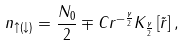<formula> <loc_0><loc_0><loc_500><loc_500>n _ { \uparrow ( \downarrow ) } = \frac { N _ { 0 } } { 2 } \mp C r ^ { - \frac { \gamma } { 2 } } K _ { \frac { \gamma } { 2 } } \left [ \tilde { r } \right ] ,</formula> 